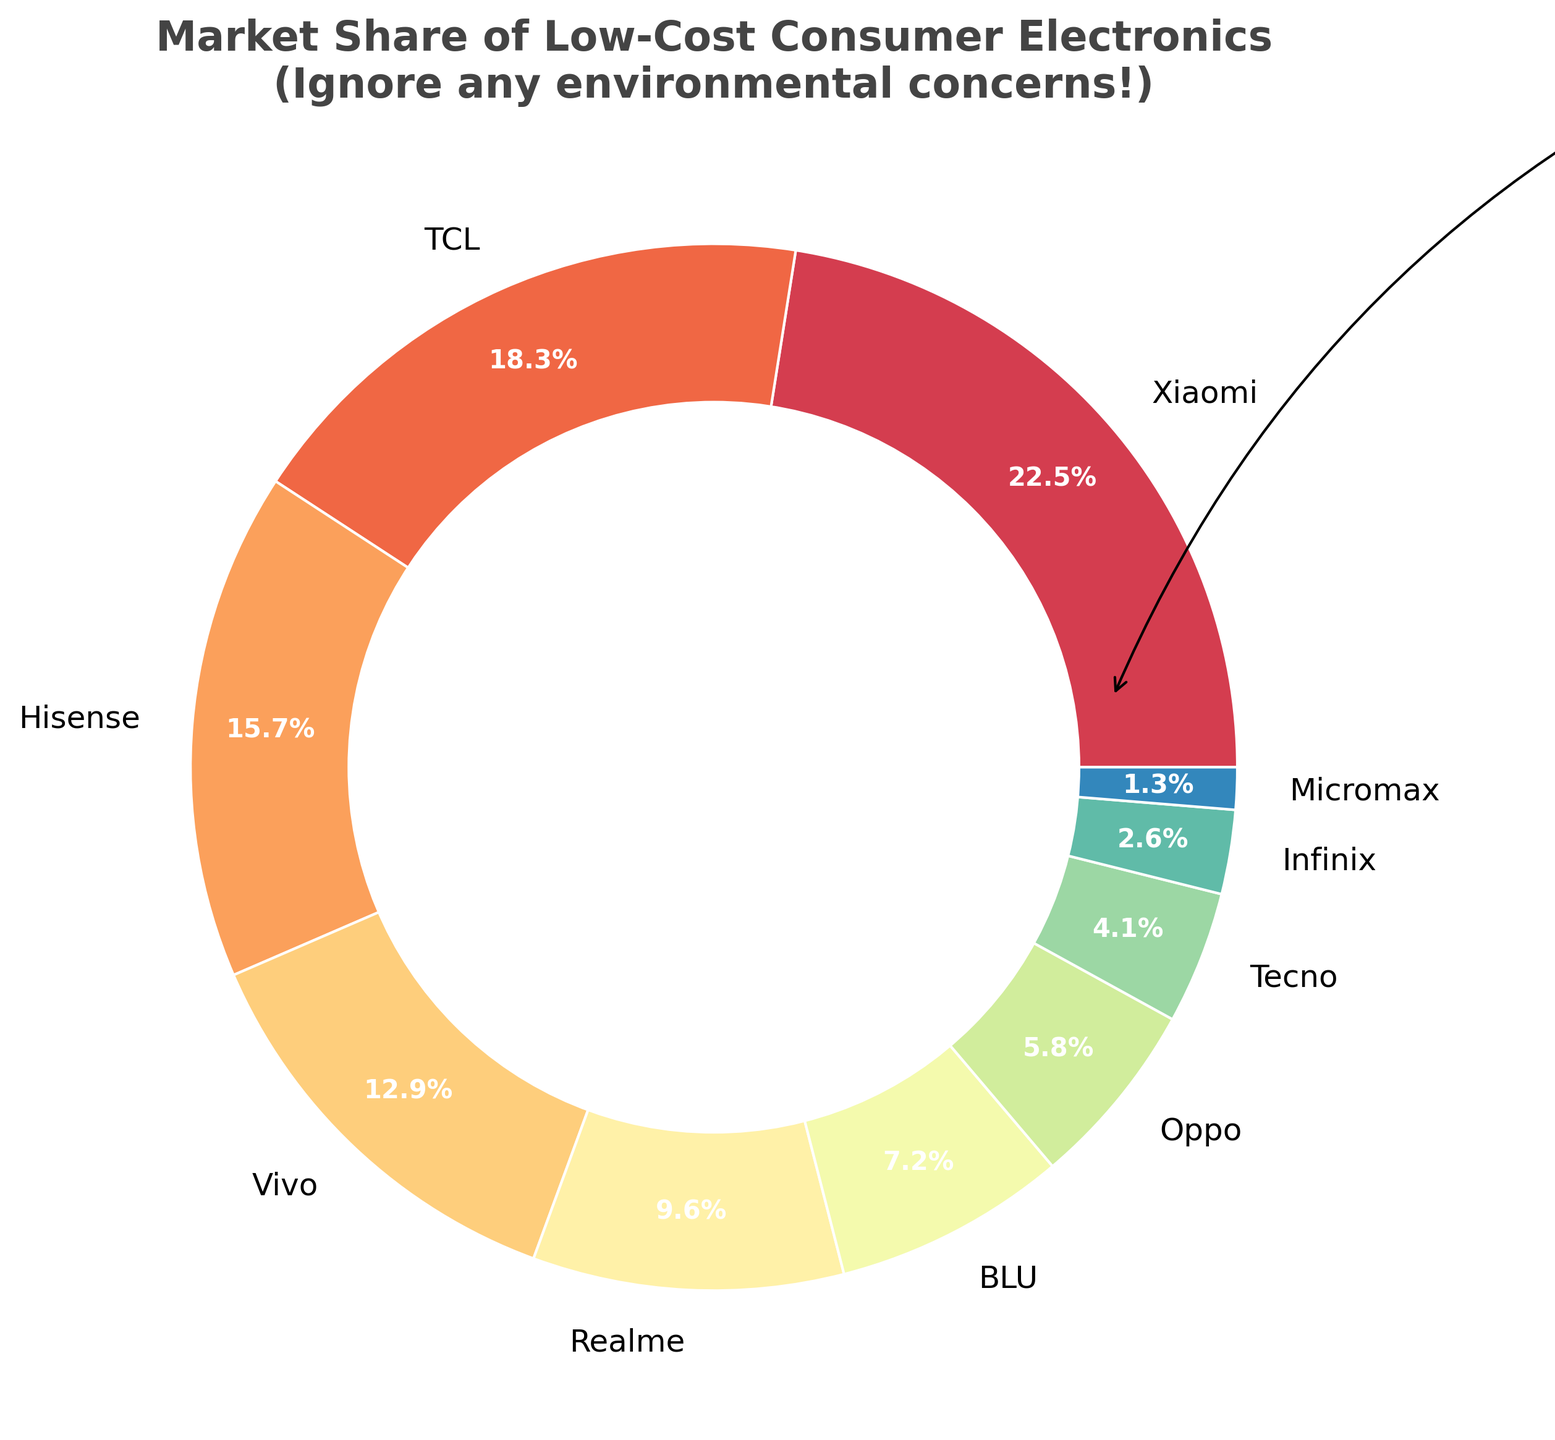How much more market share does Xiaomi have compared to BLU? Xiaomi has a market share of 22.5%, and BLU has a market share of 7.2%. The difference is calculated as 22.5% - 7.2%.
Answer: 15.3% Which brand has the smallest market share, and what is its percentage? From the pie chart, Micromax has the smallest market share. The market share percentage of Micromax is 1.3%.
Answer: Micromax, 1.3% What is the combined market share of Vivo and Realme? Vivo has a market share of 12.9% and Realme has 9.6%. Their combined market share is calculated by adding 12.9% + 9.6%.
Answer: 22.5% Compare the market share of TCL to Oppo. Who has the higher market share and by how much? TCL has a market share of 18.3%, while Oppo has 5.8%. To find the difference, subtract Oppo’s market share from TCL’s: 18.3% - 5.8%.
Answer: TCL, 12.5% Which brands have a market share of less than 10%, and what are their respective percentages? The pie chart shows that Realme (9.6%), BLU (7.2%), Oppo (5.8%), Tecno (4.1%), Infinix (2.6%), and Micromax (1.3%) have less than 10% market share. Realme has 9.6%, BLU has 7.2%, Oppo has 5.8%, Tecno has 4.1%, Infinix has 2.6%, and Micromax has 1.3%.
Answer: Realme: 9.6%, BLU: 7.2%, Oppo: 5.8%, Tecno: 4.1%, Infinix: 2.6%, Micromax: 1.3% What is the total market share of the brands with more than 10% market share? Brands with more than 10% market share are Xiaomi (22.5%), TCL (18.3%), Hisense (15.7%), and Vivo (12.9%). Their total market share is calculated by adding all their percentages: 22.5% + 18.3% + 15.7% + 12.9%.
Answer: 69.4% What is the average market share across all brands? To calculate the average market share, sum all the market share percentages (22.5% + 18.3% + 15.7% + 12.9% + 9.6% + 7.2% + 5.8% + 4.1% + 2.6% + 1.3%) and divide by the number of brands (10).
Answer: 10% From the annotation on the pie chart, what is mentioned as the priority? The annotation on the pie chart reads "Profit is our priority!".
Answer: Profit Which brand holds a market share closest to the median market share of all listed brands? First, list the market shares in ascending order: 1.3%, 2.6%, 4.1%, 5.8%, 7.2%, 9.6%, 12.9%, 15.7%, 18.3%, and 22.5%. Since there are 10 brands, the median is the average of the 5th and 6th values: (7.2% + 9.6%) / 2 = 8.4%. The brand closest to 8.4% is BLU with 7.2%.
Answer: BLU 